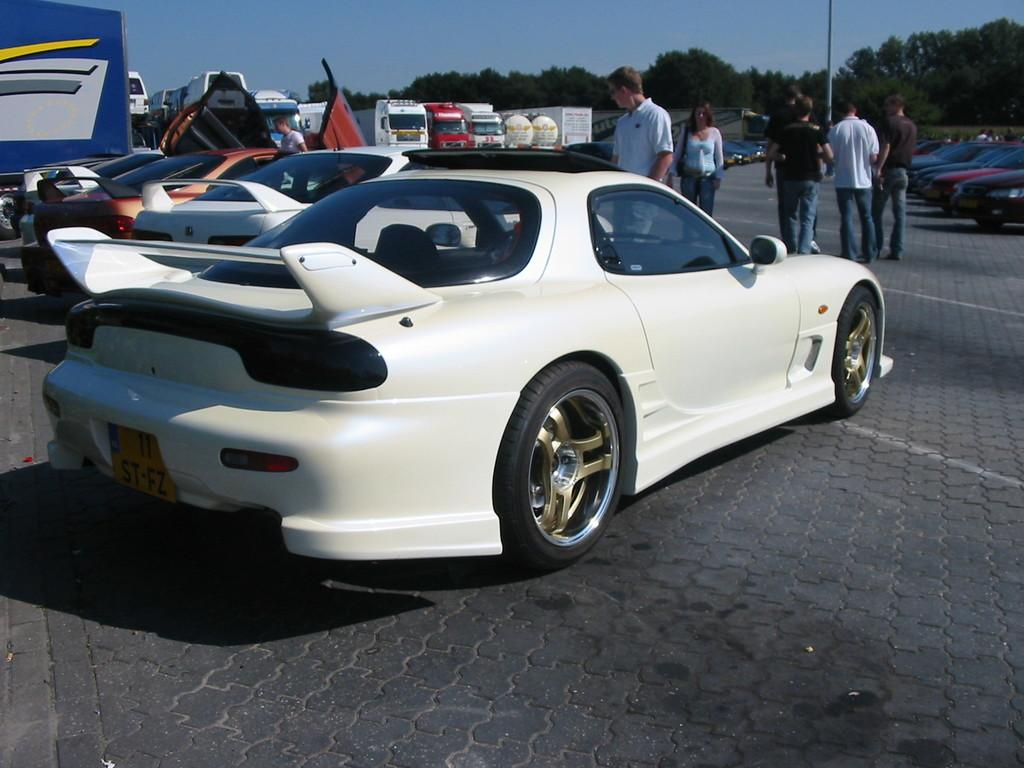What is located in the center of the image? There are vehicles in the center of the image. What else can be seen in the image besides the vehicles? There are people standing in the image. What is visible in the background of the image? The sky, trees, a pole, and other objects are visible in the background of the image. What type of bait is being used to catch the fish in the image? There is no fish or bait present in the image; it features vehicles, people, and objects in the background. 